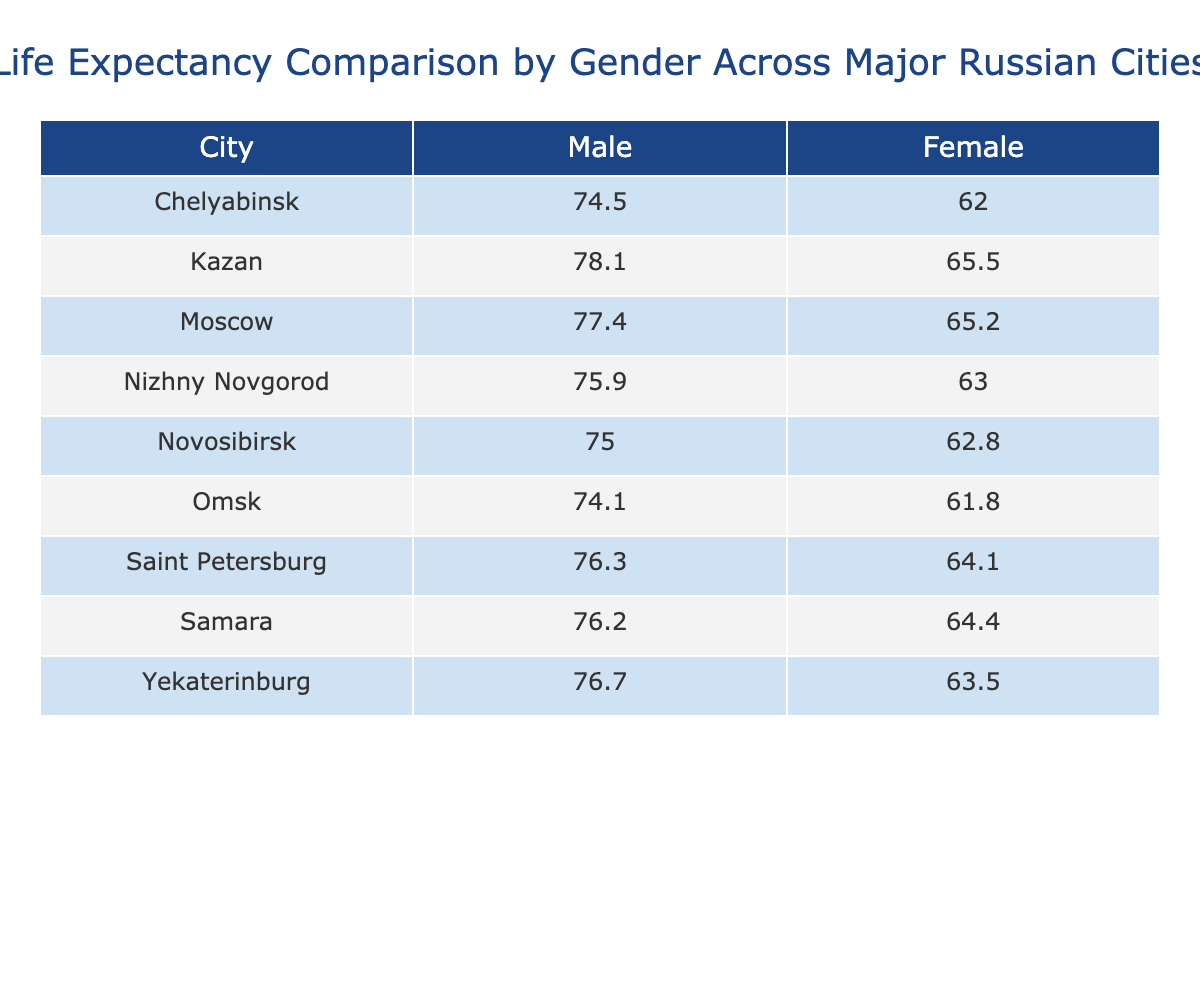What is the life expectancy of females in Kazan? The table shows the life expectancy data for Kazan, where the female category is listed as 78.1 years.
Answer: 78.1 Which city has the highest life expectancy for males? By examining the table, Kazan has the highest life expectancy for males at 65.5 years compared to the other cities listed.
Answer: Kazan What is the difference in life expectancy between males and females in Chelyabinsk? The life expectancy for males in Chelyabinsk is 62.0 years and for females is 74.5 years. The difference is 74.5 - 62.0 = 12.5 years.
Answer: 12.5 Is the life expectancy of males in Saint Petersburg greater than that in Omsk? The life expectancy for males in Saint Petersburg is 64.1 years, while in Omsk it is 61.8 years. Since 64.1 is greater than 61.8, the statement is true.
Answer: Yes What is the average life expectancy for females across all listed cities? To calculate the average, we first add the female life expectancy values: (77.4 + 76.3 + 75.0 + 76.7 + 75.9 + 78.1 + 74.5 + 76.2 + 74.1) = 605.2. There are 9 values, so the average is 605.2 / 9 = 67.2.
Answer: 67.2 What is the life expectancy of males and females in Yekaterinburg? For Yekaterinburg, the table shows that the life expectancy for males is 63.5 years and for females is 76.7 years.
Answer: 63.5 (Males), 76.7 (Females) Which city has the lowest life expectancy for females? By examining the female values, the lowest life expectancy is found in Omsk, where it is 74.1 years, lower than any other city.
Answer: Omsk Is the average life expectancy for males across these cities greater than 64 years? Adding the male life expectancy values gives us (65.2 + 64.1 + 62.8 + 63.5 + 63.0 + 65.5 + 62.0 + 64.4 + 61.8) =  510.9. Dividing by 9 gives an average of 510.9 / 9 = 56.8, which is less than 64.
Answer: No What is the total life expectancy for males in Novosibirsk and Samara? The life expectancy in Novosibirsk is 62.8 years, and in Samara it is 64.4 years. Adding these together gives a total of 62.8 + 64.4 = 127.2 years.
Answer: 127.2 